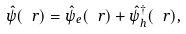<formula> <loc_0><loc_0><loc_500><loc_500>\hat { \psi } ( \ r ) = \hat { \psi } _ { e } ( \ r ) + \hat { \psi } ^ { \dagger } _ { h } ( \ r ) ,</formula> 